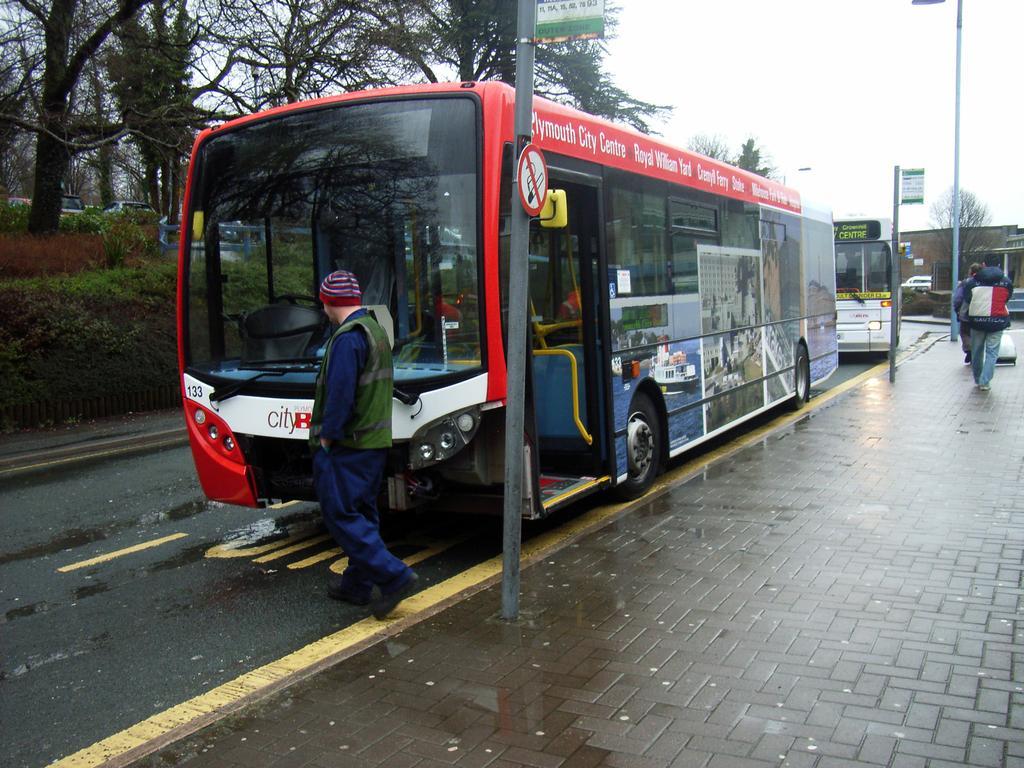Describe this image in one or two sentences. In this image we can see motor vehicles and persons on the road, poles, sign boards, fence, plants, trees and sky. 